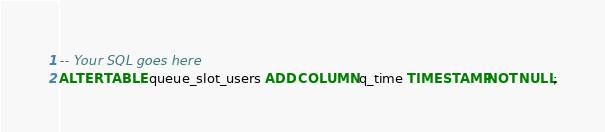Convert code to text. <code><loc_0><loc_0><loc_500><loc_500><_SQL_>-- Your SQL goes here
ALTER TABLE queue_slot_users ADD COLUMN q_time TIMESTAMP NOT NULL;
</code> 